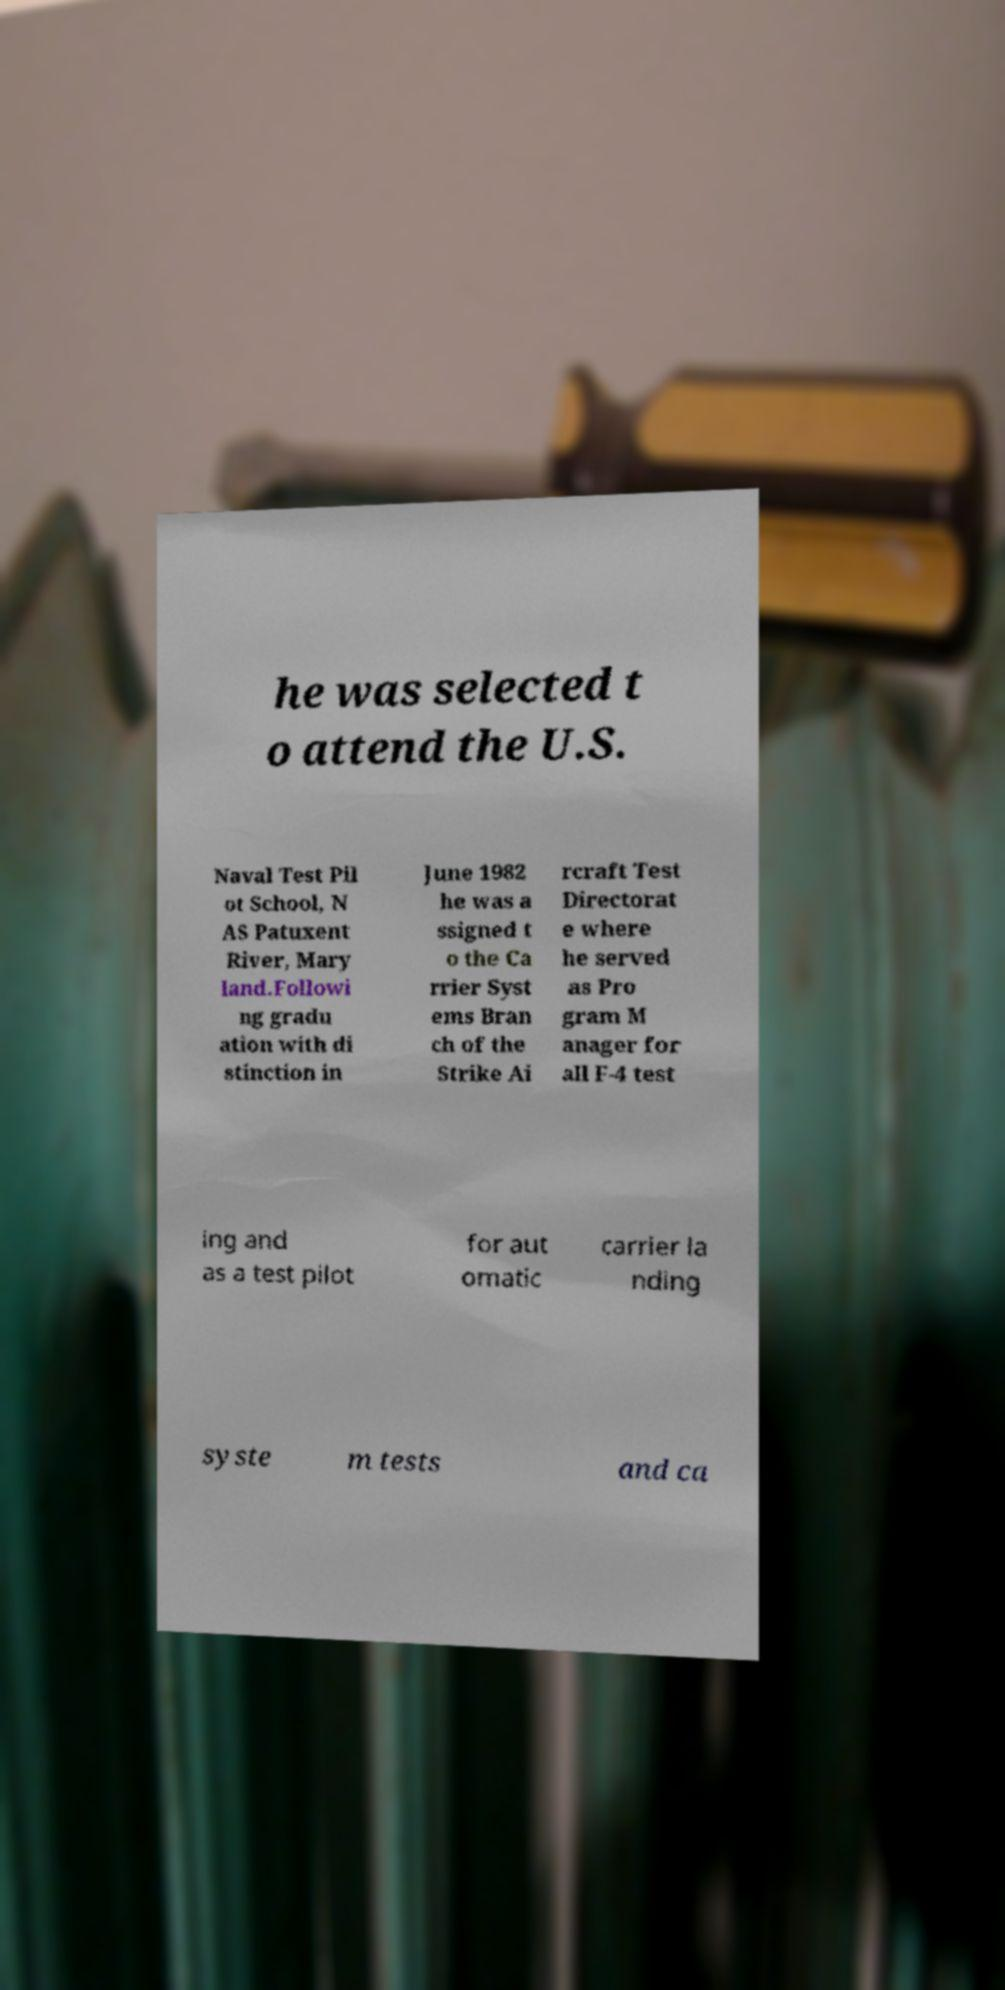Could you assist in decoding the text presented in this image and type it out clearly? he was selected t o attend the U.S. Naval Test Pil ot School, N AS Patuxent River, Mary land.Followi ng gradu ation with di stinction in June 1982 he was a ssigned t o the Ca rrier Syst ems Bran ch of the Strike Ai rcraft Test Directorat e where he served as Pro gram M anager for all F-4 test ing and as a test pilot for aut omatic carrier la nding syste m tests and ca 